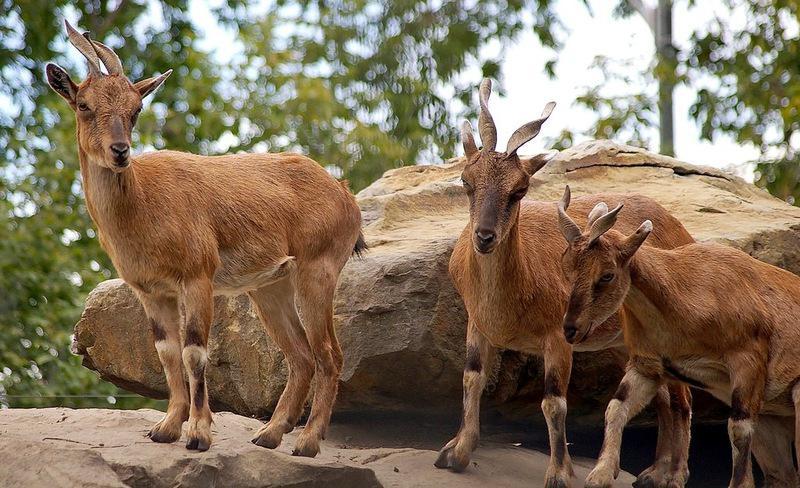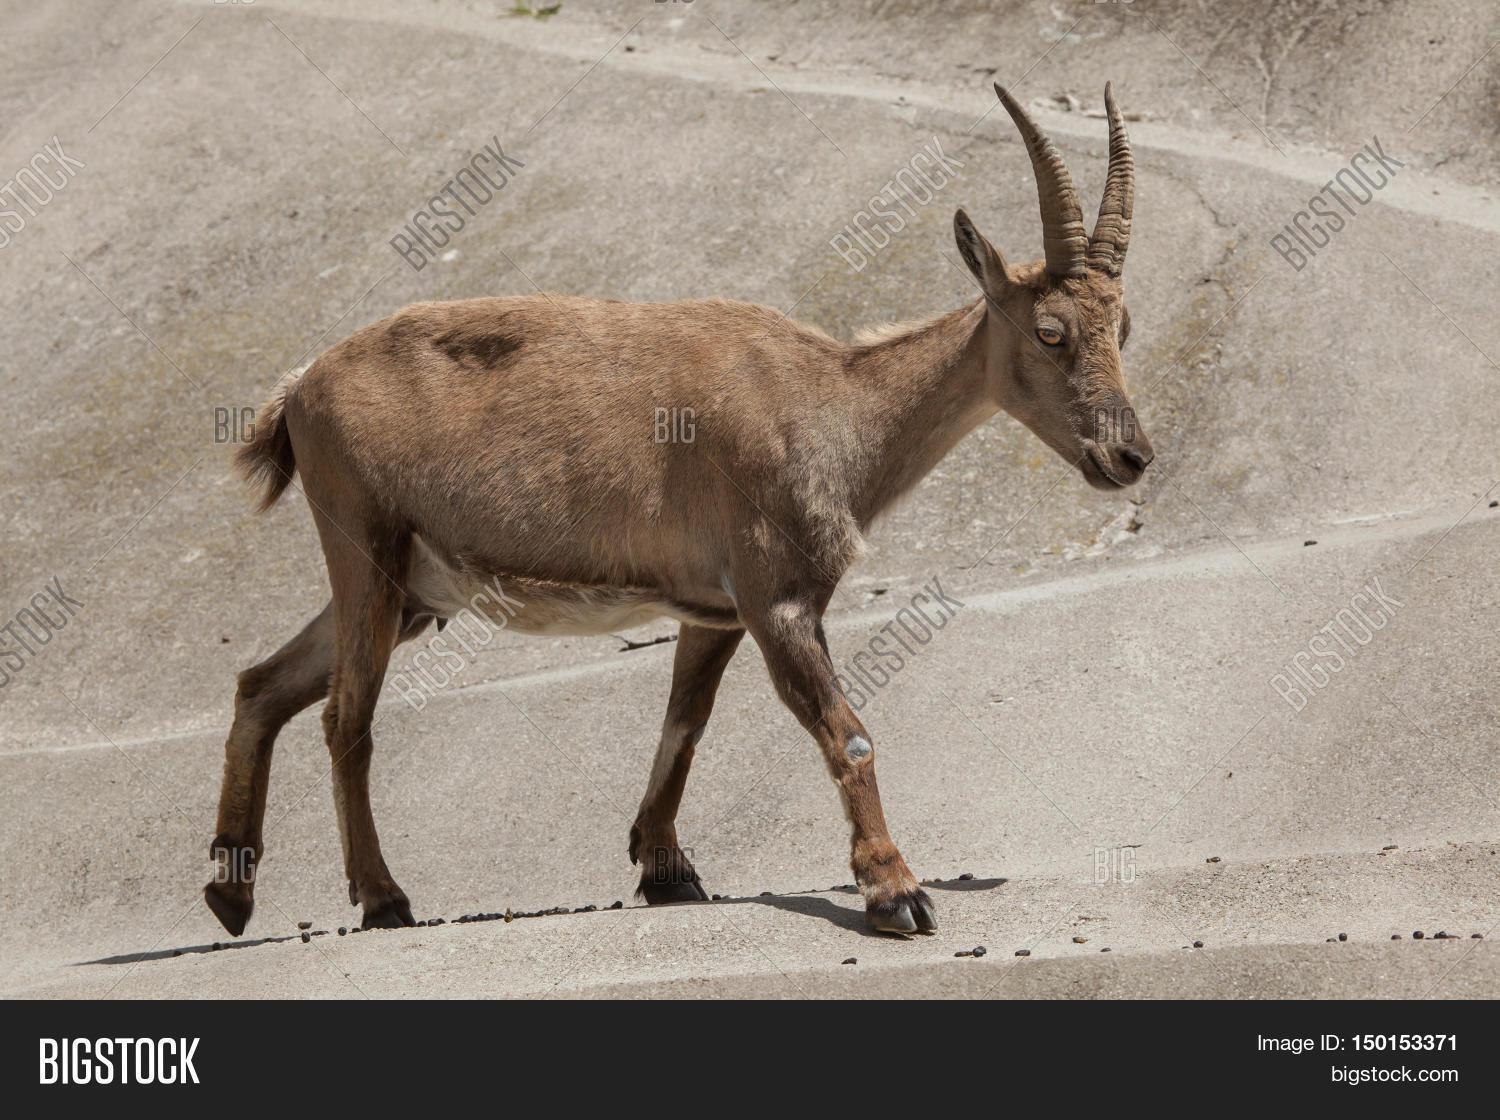The first image is the image on the left, the second image is the image on the right. Evaluate the accuracy of this statement regarding the images: "The left image has a single mammal looking to the right, the right image has a single mammal not looking to the right.". Is it true? Answer yes or no. No. The first image is the image on the left, the second image is the image on the right. For the images shown, is this caption "The left and right image contains the same number of goats with at least one one rocks." true? Answer yes or no. No. 